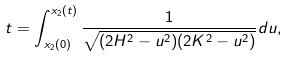Convert formula to latex. <formula><loc_0><loc_0><loc_500><loc_500>t = \int _ { x _ { 2 } ( 0 ) } ^ { x _ { 2 } ( t ) } \frac { 1 } { \sqrt { ( 2 H ^ { 2 } - u ^ { 2 } ) ( 2 K ^ { 2 } - u ^ { 2 } ) } } d u ,</formula> 